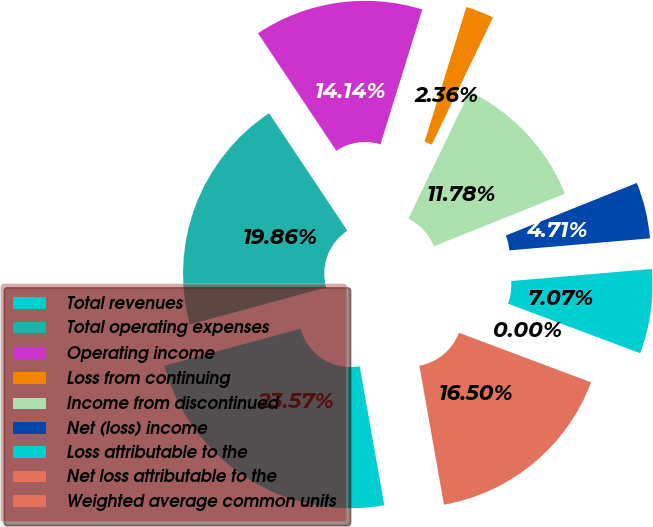<chart> <loc_0><loc_0><loc_500><loc_500><pie_chart><fcel>Total revenues<fcel>Total operating expenses<fcel>Operating income<fcel>Loss from continuing<fcel>Income from discontinued<fcel>Net (loss) income<fcel>Loss attributable to the<fcel>Net loss attributable to the<fcel>Weighted average common units<nl><fcel>23.57%<fcel>19.86%<fcel>14.14%<fcel>2.36%<fcel>11.78%<fcel>4.71%<fcel>7.07%<fcel>0.0%<fcel>16.5%<nl></chart> 